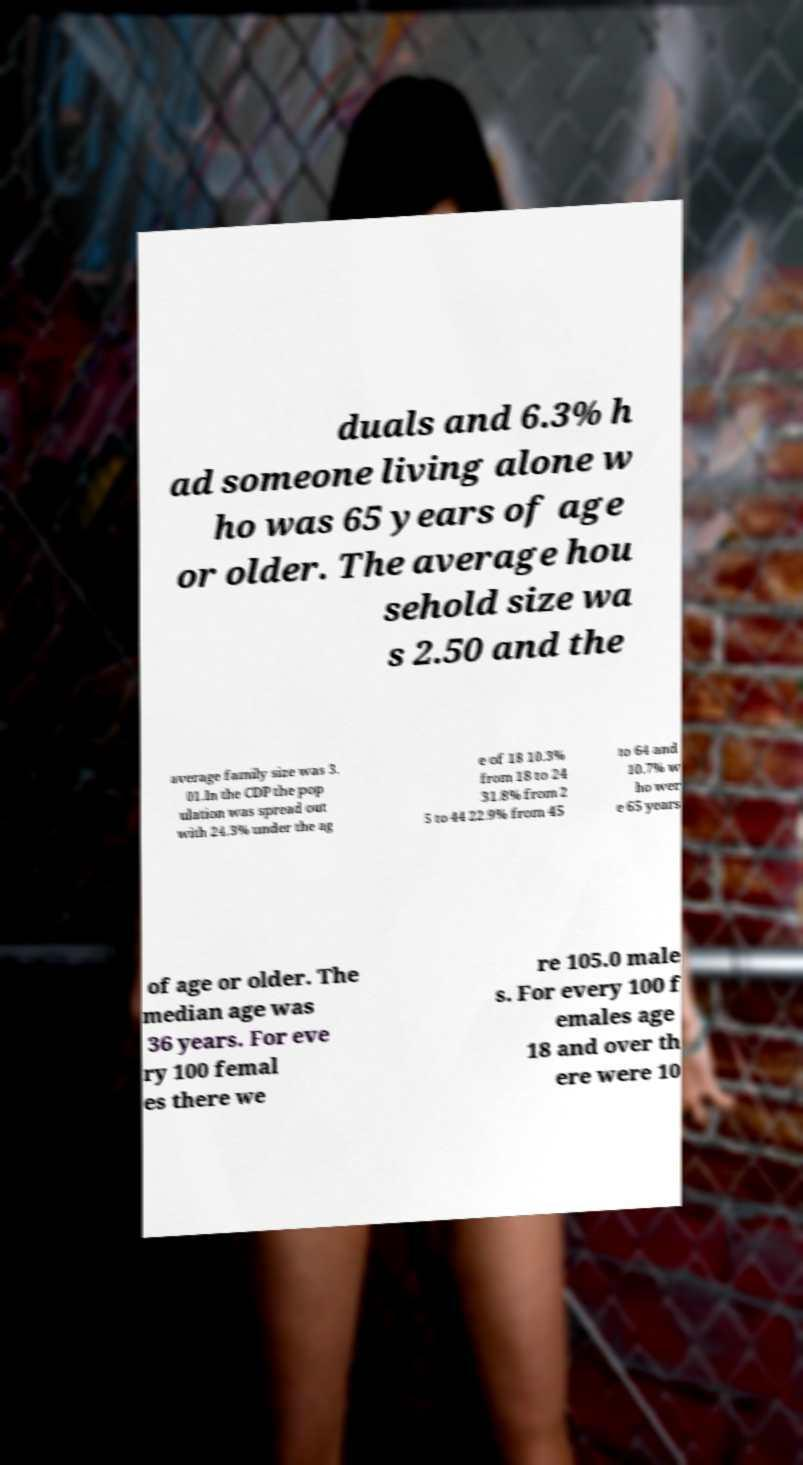Could you assist in decoding the text presented in this image and type it out clearly? duals and 6.3% h ad someone living alone w ho was 65 years of age or older. The average hou sehold size wa s 2.50 and the average family size was 3. 01.In the CDP the pop ulation was spread out with 24.3% under the ag e of 18 10.3% from 18 to 24 31.8% from 2 5 to 44 22.9% from 45 to 64 and 10.7% w ho wer e 65 years of age or older. The median age was 36 years. For eve ry 100 femal es there we re 105.0 male s. For every 100 f emales age 18 and over th ere were 10 